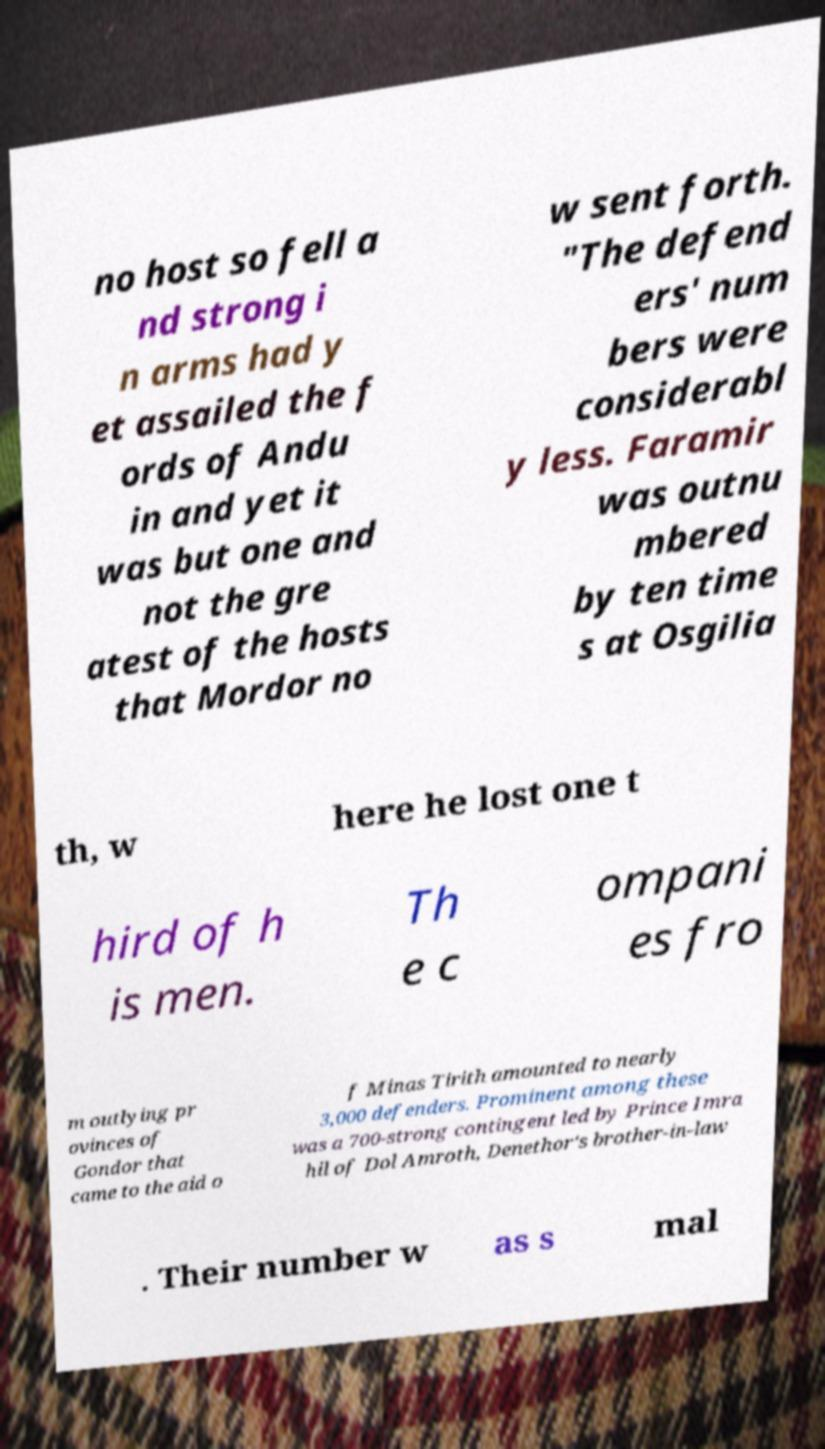Please identify and transcribe the text found in this image. no host so fell a nd strong i n arms had y et assailed the f ords of Andu in and yet it was but one and not the gre atest of the hosts that Mordor no w sent forth. "The defend ers' num bers were considerabl y less. Faramir was outnu mbered by ten time s at Osgilia th, w here he lost one t hird of h is men. Th e c ompani es fro m outlying pr ovinces of Gondor that came to the aid o f Minas Tirith amounted to nearly 3,000 defenders. Prominent among these was a 700-strong contingent led by Prince Imra hil of Dol Amroth, Denethor's brother-in-law . Their number w as s mal 